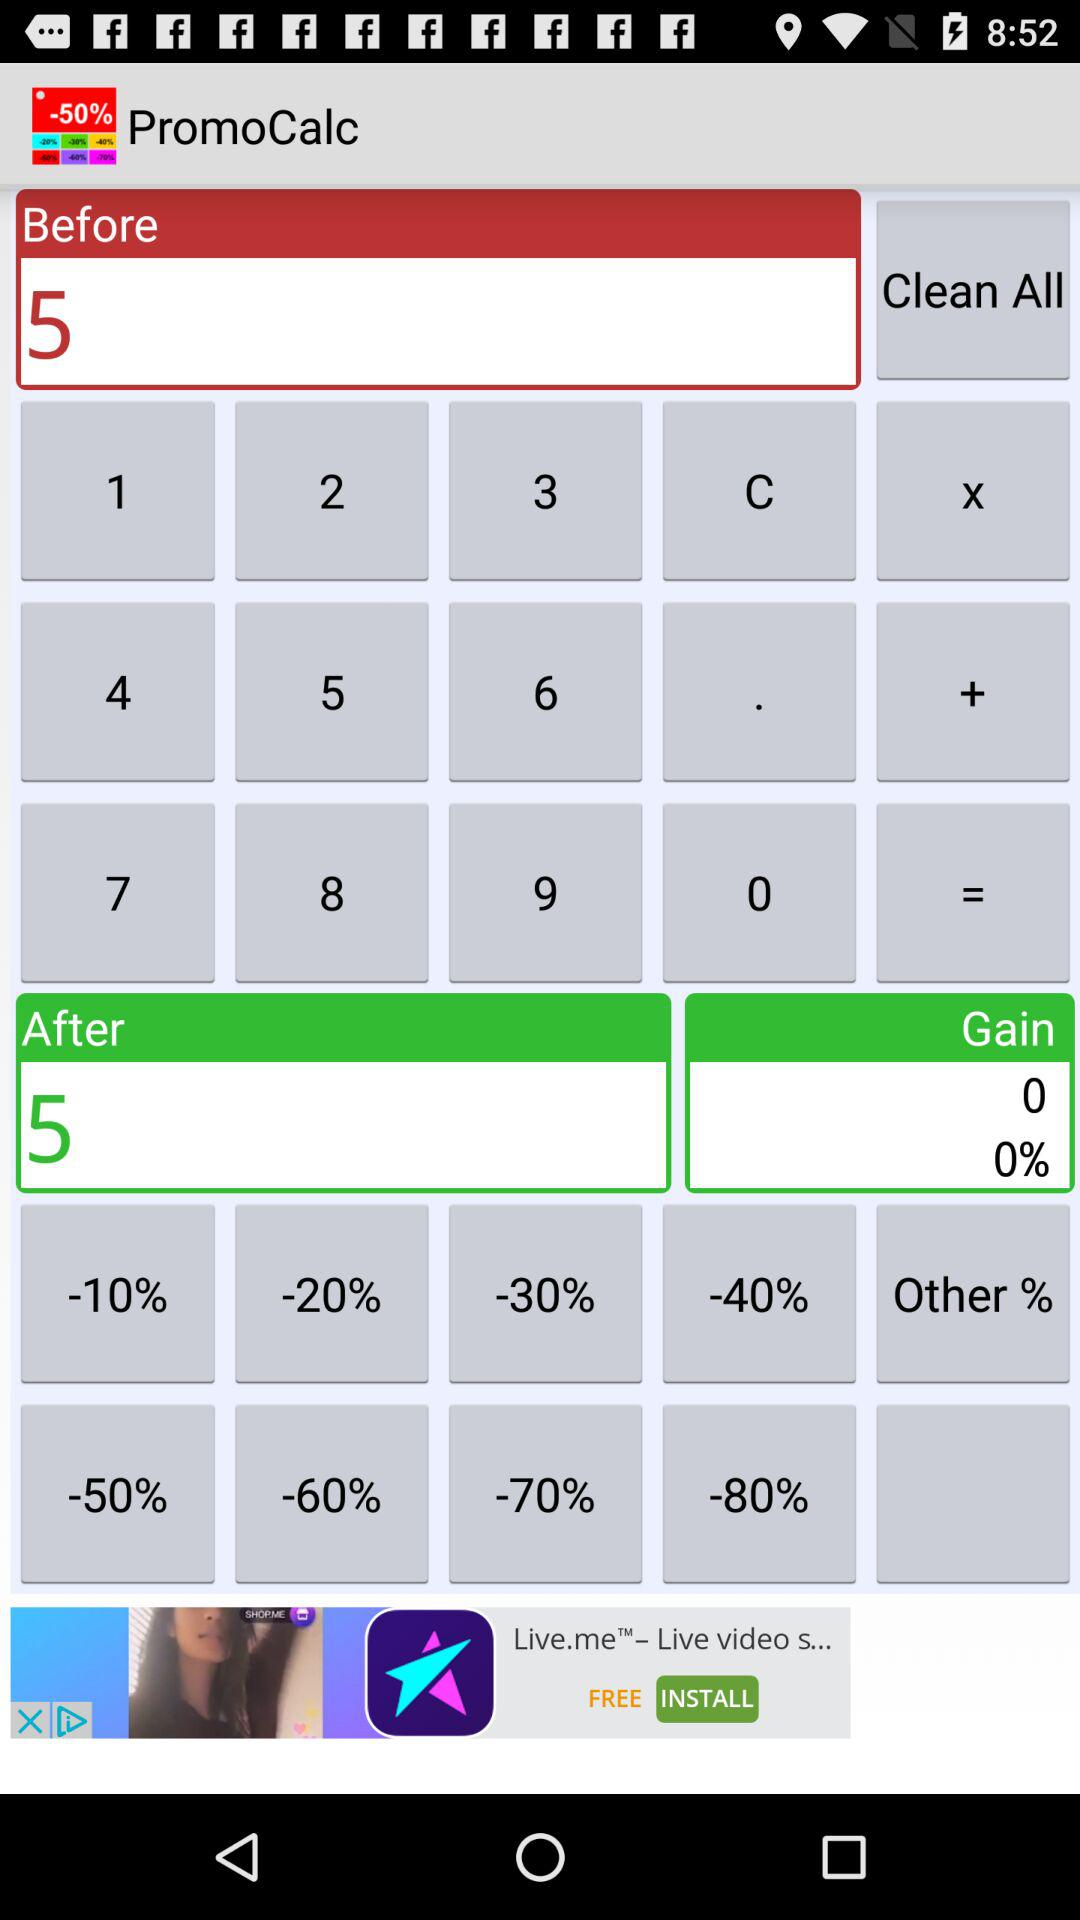What is the gain percentage? The gain percentage is 0. 